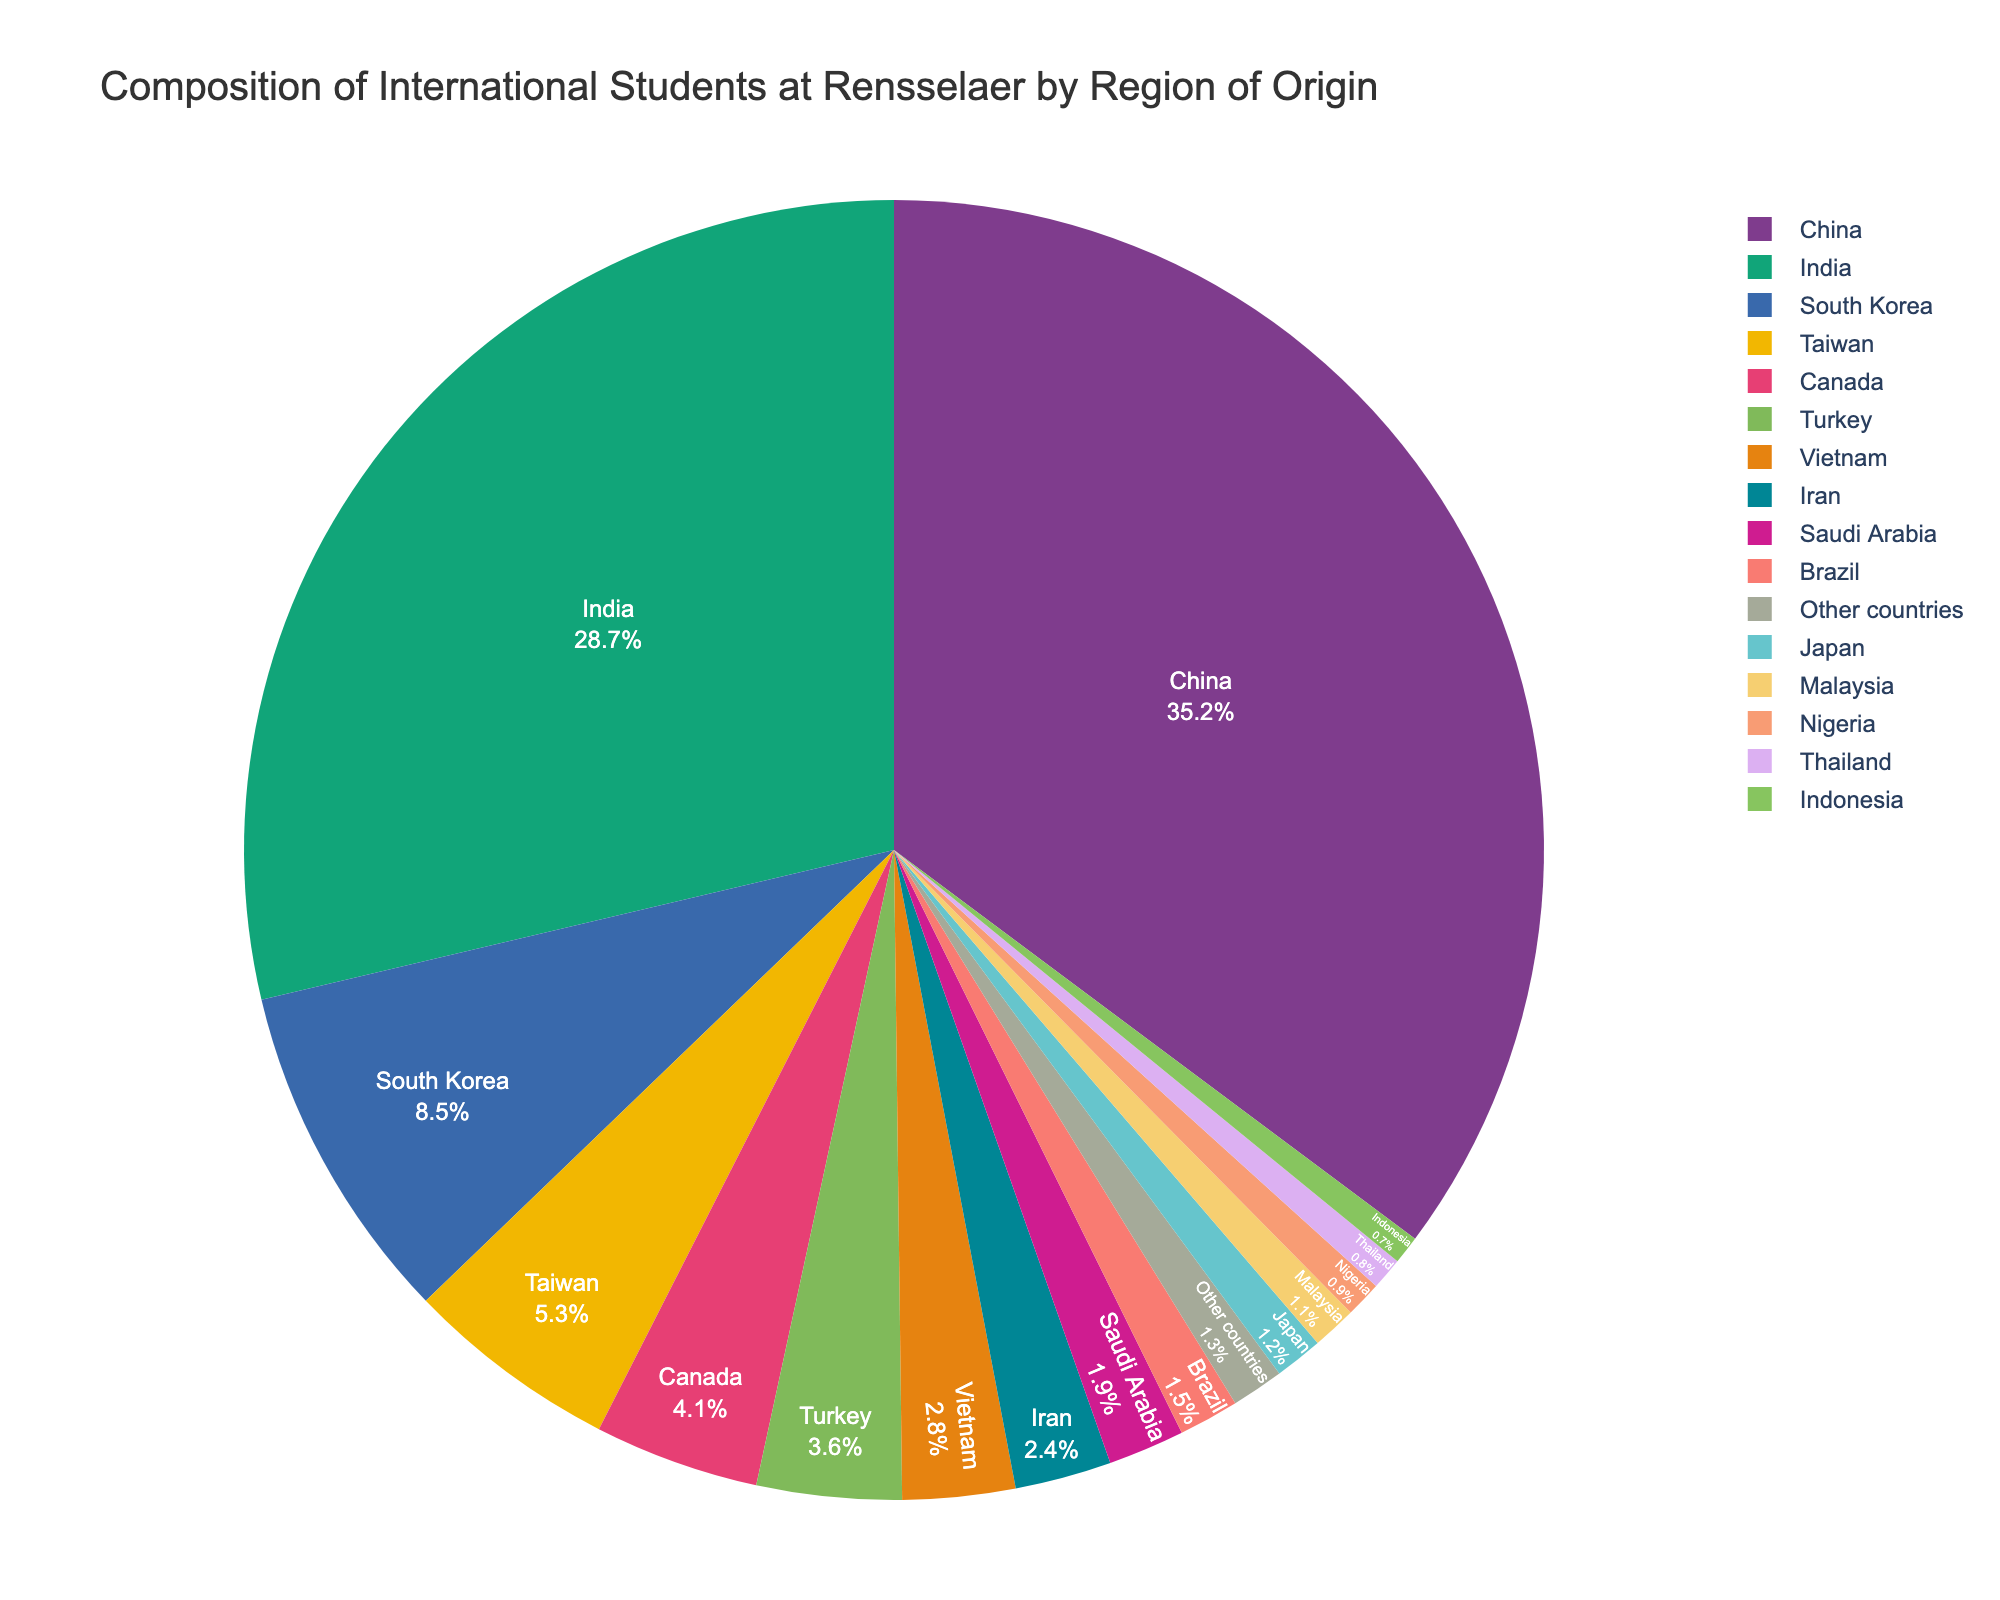What is the percentage of international students from China and India combined? To find the combined percentage, add the percentages for China (35.2%) and India (28.7%). The sum is 35.2% + 28.7% = 63.9%.
Answer: 63.9% Which region has the lowest percentage of international students represented in the pie chart? According to the data, Indonesia has the lowest percentage at 0.7%.
Answer: Indonesia How many regions have a percentage of international students greater than 10%? Only two regions have percentages greater than 10%: China (35.2%) and India (28.7%).
Answer: 2 Which region has a higher percentage of international students, Taiwan or Vietnam? Taiwan has a percentage of 5.3%, which is higher than Vietnam's 2.8%.
Answer: Taiwan What is the difference in percentage between students from South Korea and Turkey? To find the difference, subtract Turkey's percentage (3.6%) from South Korea's percentage (8.5%). The difference is 8.5% - 3.6% = 4.9%.
Answer: 4.9% How many regions contribute less than 2% of international students each? Regions that contribute less than 2% are Saudi Arabia (1.9%), Brazil (1.5%), Japan (1.2%), Malaysia (1.1%), Nigeria (0.9%), Thailand (0.8%), and Indonesia (0.7%). This makes a total of 7 regions.
Answer: 7 What is the total percentage of international students from countries other than China and India? To find the total, subtract the combined percentage of China and India (63.9%) from 100%. The result is 100% - 63.9% = 36.1%.
Answer: 36.1% Which regions collectively make up approximately 15% of the international student population? Adding the percentages of South Korea (8.5%), Taiwan (5.3%), and Other countries (1.3%) gives a total of 8.5% + 5.3% + 1.3% = 15.1%, which is approximately 15%.
Answer: South Korea, Taiwan, Other countries Are there more international students from Canada or Turkey? Canada has 4.1% and Turkey has 3.6%, so there are more international students from Canada.
Answer: Canada 